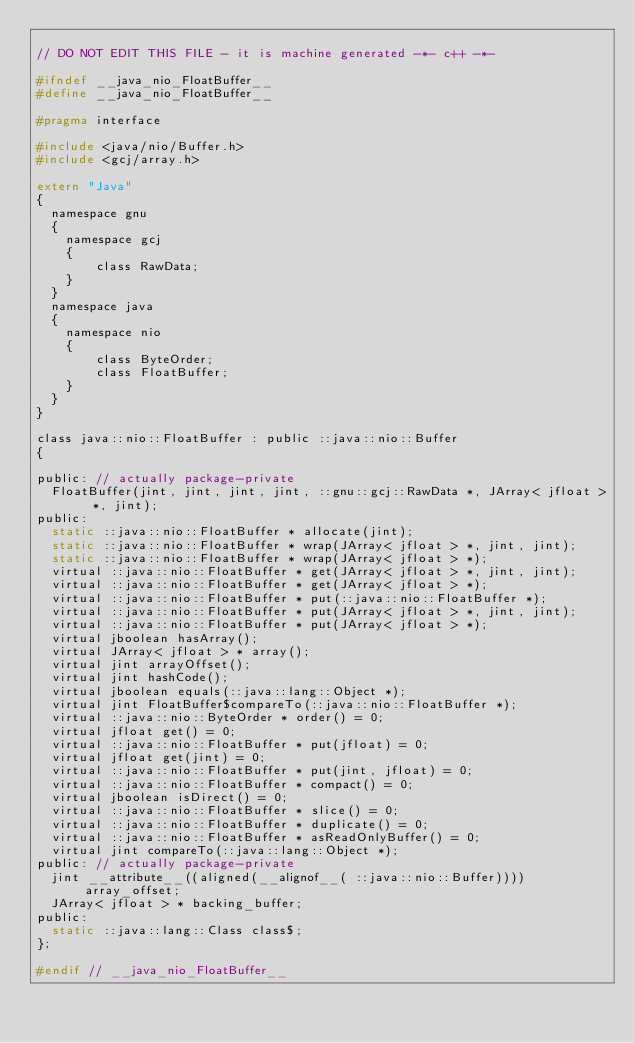Convert code to text. <code><loc_0><loc_0><loc_500><loc_500><_C_>
// DO NOT EDIT THIS FILE - it is machine generated -*- c++ -*-

#ifndef __java_nio_FloatBuffer__
#define __java_nio_FloatBuffer__

#pragma interface

#include <java/nio/Buffer.h>
#include <gcj/array.h>

extern "Java"
{
  namespace gnu
  {
    namespace gcj
    {
        class RawData;
    }
  }
  namespace java
  {
    namespace nio
    {
        class ByteOrder;
        class FloatBuffer;
    }
  }
}

class java::nio::FloatBuffer : public ::java::nio::Buffer
{

public: // actually package-private
  FloatBuffer(jint, jint, jint, jint, ::gnu::gcj::RawData *, JArray< jfloat > *, jint);
public:
  static ::java::nio::FloatBuffer * allocate(jint);
  static ::java::nio::FloatBuffer * wrap(JArray< jfloat > *, jint, jint);
  static ::java::nio::FloatBuffer * wrap(JArray< jfloat > *);
  virtual ::java::nio::FloatBuffer * get(JArray< jfloat > *, jint, jint);
  virtual ::java::nio::FloatBuffer * get(JArray< jfloat > *);
  virtual ::java::nio::FloatBuffer * put(::java::nio::FloatBuffer *);
  virtual ::java::nio::FloatBuffer * put(JArray< jfloat > *, jint, jint);
  virtual ::java::nio::FloatBuffer * put(JArray< jfloat > *);
  virtual jboolean hasArray();
  virtual JArray< jfloat > * array();
  virtual jint arrayOffset();
  virtual jint hashCode();
  virtual jboolean equals(::java::lang::Object *);
  virtual jint FloatBuffer$compareTo(::java::nio::FloatBuffer *);
  virtual ::java::nio::ByteOrder * order() = 0;
  virtual jfloat get() = 0;
  virtual ::java::nio::FloatBuffer * put(jfloat) = 0;
  virtual jfloat get(jint) = 0;
  virtual ::java::nio::FloatBuffer * put(jint, jfloat) = 0;
  virtual ::java::nio::FloatBuffer * compact() = 0;
  virtual jboolean isDirect() = 0;
  virtual ::java::nio::FloatBuffer * slice() = 0;
  virtual ::java::nio::FloatBuffer * duplicate() = 0;
  virtual ::java::nio::FloatBuffer * asReadOnlyBuffer() = 0;
  virtual jint compareTo(::java::lang::Object *);
public: // actually package-private
  jint __attribute__((aligned(__alignof__( ::java::nio::Buffer)))) array_offset;
  JArray< jfloat > * backing_buffer;
public:
  static ::java::lang::Class class$;
};

#endif // __java_nio_FloatBuffer__
</code> 